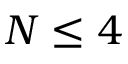Convert formula to latex. <formula><loc_0><loc_0><loc_500><loc_500>N \leq 4</formula> 